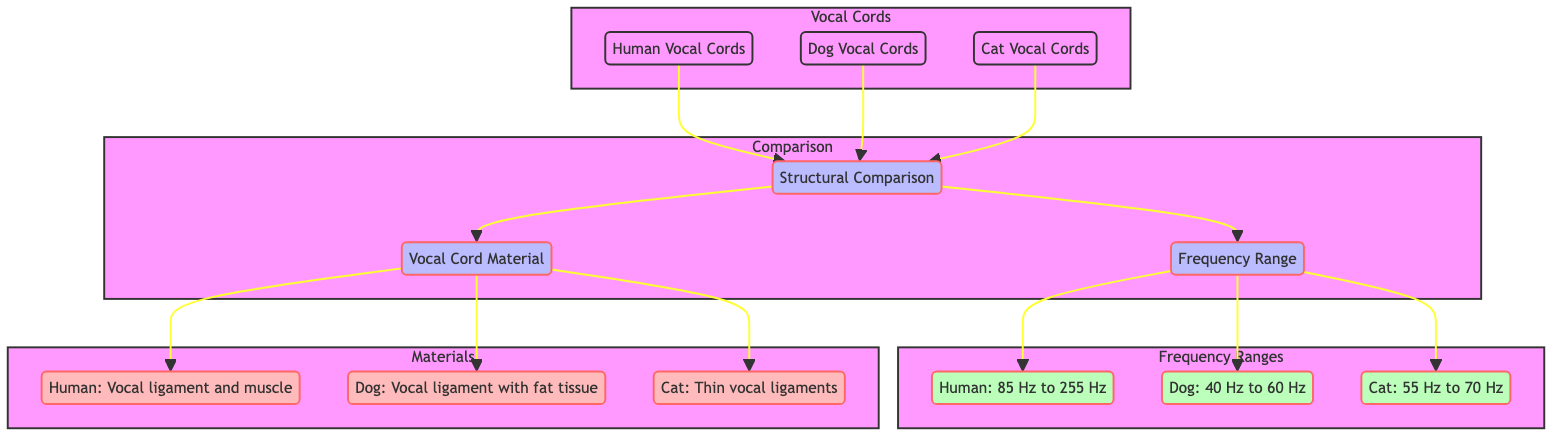What are the frequency ranges for humans? The diagram indicates that the frequency range for humans is represented in the "Frequency Ranges" section, specifically labeled as "Human: 85 Hz to 255 Hz."
Answer: 85 Hz to 255 Hz What material constitutes human vocal cords? In the "Materials" section of the diagram, it states that human vocal cords are made of "Vocal ligament and muscle."
Answer: Vocal ligament and muscle How many types of animals are compared in the diagram? There are three types of animals included in the diagram: humans, dogs, and cats. This can be counted from the "Vocal Cords" subgraph.
Answer: 3 Which animal has the lowest frequency range? By evaluating the "Frequency Ranges" section, it shows that dogs have the lowest frequency range of "Dog: 40 Hz to 60 Hz."
Answer: Dog: 40 Hz to 60 Hz What is the structure that connects all vocal cord types in the diagram? The "Comparison" subgraph illustrates the "Structural Comparison" as the connecting element among the three vocal cord types.
Answer: Structural Comparison What vocal cord material do dogs possess? Referring to the "Materials" section, the vocal cord material for dogs is noted as "Vocal ligament with fat tissue."
Answer: Vocal ligament with fat tissue Which vocal cord type has thin ligaments? Looking at the "Materials" section for cats, it states "Thin vocal ligaments" as their distinguishing feature.
Answer: Thin vocal ligaments What is the relationship between frequency range and vocal cord material? The arrows in the diagram show a direct connection indicating that both "Frequency Range" and "Vocal Cord Material" are compared under the "Structural Comparison" for different vocal cord types.
Answer: Direct Comparison What is the frequency range for cats? Under the "Frequency Ranges" section, the frequency range for cats is labeled as "Cat: 55 Hz to 70 Hz."
Answer: Cat: 55 Hz to 70 Hz 